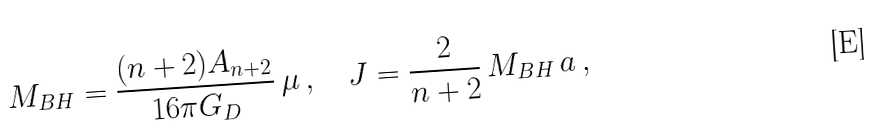Convert formula to latex. <formula><loc_0><loc_0><loc_500><loc_500>M _ { B H } = \frac { ( n + 2 ) A _ { n + 2 } } { 1 6 \pi G _ { D } } \, \mu \, , \quad J = \frac { 2 } { n + 2 } \, M _ { B H } \, a \, ,</formula> 